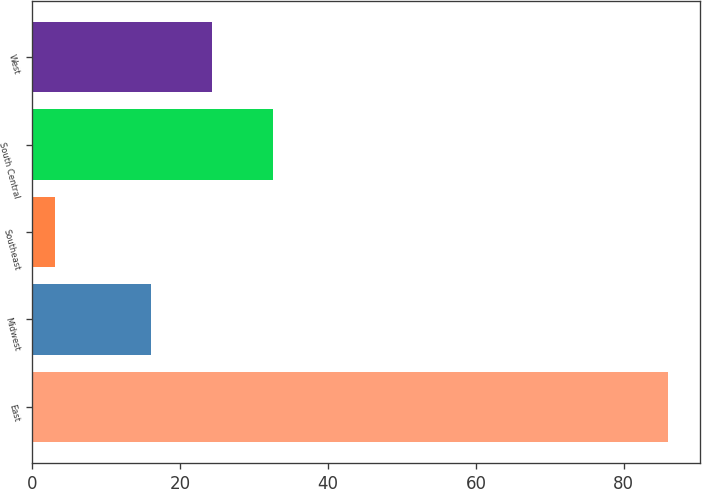Convert chart. <chart><loc_0><loc_0><loc_500><loc_500><bar_chart><fcel>East<fcel>Midwest<fcel>Southeast<fcel>South Central<fcel>West<nl><fcel>86<fcel>16<fcel>3<fcel>32.6<fcel>24.3<nl></chart> 